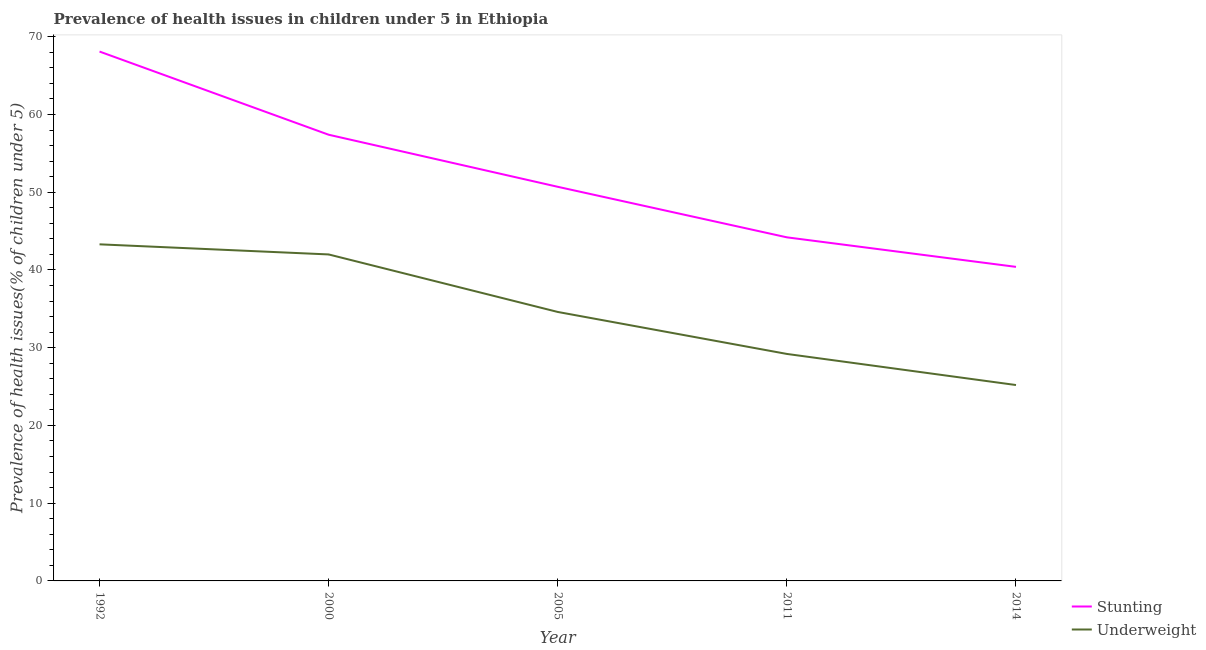What is the percentage of stunted children in 1992?
Your answer should be compact. 68.1. Across all years, what is the maximum percentage of stunted children?
Provide a short and direct response. 68.1. Across all years, what is the minimum percentage of stunted children?
Provide a succinct answer. 40.4. In which year was the percentage of underweight children maximum?
Give a very brief answer. 1992. What is the total percentage of underweight children in the graph?
Provide a short and direct response. 174.3. What is the difference between the percentage of underweight children in 1992 and that in 2005?
Give a very brief answer. 8.7. What is the difference between the percentage of underweight children in 2005 and the percentage of stunted children in 2000?
Offer a very short reply. -22.8. What is the average percentage of underweight children per year?
Offer a very short reply. 34.86. In the year 2014, what is the difference between the percentage of stunted children and percentage of underweight children?
Provide a succinct answer. 15.2. In how many years, is the percentage of stunted children greater than 20 %?
Your answer should be very brief. 5. What is the ratio of the percentage of underweight children in 2005 to that in 2011?
Provide a short and direct response. 1.18. Is the difference between the percentage of stunted children in 2000 and 2014 greater than the difference between the percentage of underweight children in 2000 and 2014?
Keep it short and to the point. Yes. What is the difference between the highest and the second highest percentage of stunted children?
Provide a short and direct response. 10.7. What is the difference between the highest and the lowest percentage of underweight children?
Make the answer very short. 18.1. Is the sum of the percentage of stunted children in 2000 and 2011 greater than the maximum percentage of underweight children across all years?
Your answer should be compact. Yes. Does the percentage of stunted children monotonically increase over the years?
Ensure brevity in your answer.  No. How many lines are there?
Offer a very short reply. 2. What is the difference between two consecutive major ticks on the Y-axis?
Make the answer very short. 10. Are the values on the major ticks of Y-axis written in scientific E-notation?
Your answer should be very brief. No. Does the graph contain any zero values?
Make the answer very short. No. Does the graph contain grids?
Provide a short and direct response. No. How many legend labels are there?
Ensure brevity in your answer.  2. What is the title of the graph?
Your response must be concise. Prevalence of health issues in children under 5 in Ethiopia. What is the label or title of the Y-axis?
Make the answer very short. Prevalence of health issues(% of children under 5). What is the Prevalence of health issues(% of children under 5) of Stunting in 1992?
Keep it short and to the point. 68.1. What is the Prevalence of health issues(% of children under 5) in Underweight in 1992?
Offer a terse response. 43.3. What is the Prevalence of health issues(% of children under 5) of Stunting in 2000?
Offer a terse response. 57.4. What is the Prevalence of health issues(% of children under 5) in Underweight in 2000?
Your response must be concise. 42. What is the Prevalence of health issues(% of children under 5) of Stunting in 2005?
Provide a short and direct response. 50.7. What is the Prevalence of health issues(% of children under 5) in Underweight in 2005?
Make the answer very short. 34.6. What is the Prevalence of health issues(% of children under 5) of Stunting in 2011?
Offer a terse response. 44.2. What is the Prevalence of health issues(% of children under 5) in Underweight in 2011?
Your answer should be compact. 29.2. What is the Prevalence of health issues(% of children under 5) of Stunting in 2014?
Provide a short and direct response. 40.4. What is the Prevalence of health issues(% of children under 5) in Underweight in 2014?
Give a very brief answer. 25.2. Across all years, what is the maximum Prevalence of health issues(% of children under 5) in Stunting?
Make the answer very short. 68.1. Across all years, what is the maximum Prevalence of health issues(% of children under 5) in Underweight?
Offer a terse response. 43.3. Across all years, what is the minimum Prevalence of health issues(% of children under 5) in Stunting?
Offer a terse response. 40.4. Across all years, what is the minimum Prevalence of health issues(% of children under 5) in Underweight?
Your answer should be compact. 25.2. What is the total Prevalence of health issues(% of children under 5) in Stunting in the graph?
Offer a terse response. 260.8. What is the total Prevalence of health issues(% of children under 5) in Underweight in the graph?
Offer a terse response. 174.3. What is the difference between the Prevalence of health issues(% of children under 5) in Underweight in 1992 and that in 2000?
Give a very brief answer. 1.3. What is the difference between the Prevalence of health issues(% of children under 5) of Stunting in 1992 and that in 2005?
Provide a succinct answer. 17.4. What is the difference between the Prevalence of health issues(% of children under 5) in Underweight in 1992 and that in 2005?
Offer a terse response. 8.7. What is the difference between the Prevalence of health issues(% of children under 5) of Stunting in 1992 and that in 2011?
Your response must be concise. 23.9. What is the difference between the Prevalence of health issues(% of children under 5) in Underweight in 1992 and that in 2011?
Offer a terse response. 14.1. What is the difference between the Prevalence of health issues(% of children under 5) in Stunting in 1992 and that in 2014?
Provide a succinct answer. 27.7. What is the difference between the Prevalence of health issues(% of children under 5) in Underweight in 1992 and that in 2014?
Offer a very short reply. 18.1. What is the difference between the Prevalence of health issues(% of children under 5) in Stunting in 2000 and that in 2005?
Give a very brief answer. 6.7. What is the difference between the Prevalence of health issues(% of children under 5) in Stunting in 2000 and that in 2011?
Your answer should be compact. 13.2. What is the difference between the Prevalence of health issues(% of children under 5) in Underweight in 2000 and that in 2011?
Ensure brevity in your answer.  12.8. What is the difference between the Prevalence of health issues(% of children under 5) of Stunting in 2005 and that in 2014?
Your answer should be very brief. 10.3. What is the difference between the Prevalence of health issues(% of children under 5) in Stunting in 2011 and that in 2014?
Offer a terse response. 3.8. What is the difference between the Prevalence of health issues(% of children under 5) of Underweight in 2011 and that in 2014?
Ensure brevity in your answer.  4. What is the difference between the Prevalence of health issues(% of children under 5) of Stunting in 1992 and the Prevalence of health issues(% of children under 5) of Underweight in 2000?
Provide a succinct answer. 26.1. What is the difference between the Prevalence of health issues(% of children under 5) of Stunting in 1992 and the Prevalence of health issues(% of children under 5) of Underweight in 2005?
Make the answer very short. 33.5. What is the difference between the Prevalence of health issues(% of children under 5) of Stunting in 1992 and the Prevalence of health issues(% of children under 5) of Underweight in 2011?
Make the answer very short. 38.9. What is the difference between the Prevalence of health issues(% of children under 5) of Stunting in 1992 and the Prevalence of health issues(% of children under 5) of Underweight in 2014?
Offer a terse response. 42.9. What is the difference between the Prevalence of health issues(% of children under 5) of Stunting in 2000 and the Prevalence of health issues(% of children under 5) of Underweight in 2005?
Offer a terse response. 22.8. What is the difference between the Prevalence of health issues(% of children under 5) in Stunting in 2000 and the Prevalence of health issues(% of children under 5) in Underweight in 2011?
Give a very brief answer. 28.2. What is the difference between the Prevalence of health issues(% of children under 5) of Stunting in 2000 and the Prevalence of health issues(% of children under 5) of Underweight in 2014?
Provide a succinct answer. 32.2. What is the difference between the Prevalence of health issues(% of children under 5) in Stunting in 2005 and the Prevalence of health issues(% of children under 5) in Underweight in 2011?
Keep it short and to the point. 21.5. What is the difference between the Prevalence of health issues(% of children under 5) in Stunting in 2005 and the Prevalence of health issues(% of children under 5) in Underweight in 2014?
Give a very brief answer. 25.5. What is the average Prevalence of health issues(% of children under 5) in Stunting per year?
Offer a very short reply. 52.16. What is the average Prevalence of health issues(% of children under 5) in Underweight per year?
Give a very brief answer. 34.86. In the year 1992, what is the difference between the Prevalence of health issues(% of children under 5) of Stunting and Prevalence of health issues(% of children under 5) of Underweight?
Keep it short and to the point. 24.8. What is the ratio of the Prevalence of health issues(% of children under 5) in Stunting in 1992 to that in 2000?
Your answer should be compact. 1.19. What is the ratio of the Prevalence of health issues(% of children under 5) in Underweight in 1992 to that in 2000?
Give a very brief answer. 1.03. What is the ratio of the Prevalence of health issues(% of children under 5) of Stunting in 1992 to that in 2005?
Provide a succinct answer. 1.34. What is the ratio of the Prevalence of health issues(% of children under 5) of Underweight in 1992 to that in 2005?
Ensure brevity in your answer.  1.25. What is the ratio of the Prevalence of health issues(% of children under 5) of Stunting in 1992 to that in 2011?
Your answer should be compact. 1.54. What is the ratio of the Prevalence of health issues(% of children under 5) in Underweight in 1992 to that in 2011?
Provide a succinct answer. 1.48. What is the ratio of the Prevalence of health issues(% of children under 5) in Stunting in 1992 to that in 2014?
Give a very brief answer. 1.69. What is the ratio of the Prevalence of health issues(% of children under 5) of Underweight in 1992 to that in 2014?
Give a very brief answer. 1.72. What is the ratio of the Prevalence of health issues(% of children under 5) in Stunting in 2000 to that in 2005?
Ensure brevity in your answer.  1.13. What is the ratio of the Prevalence of health issues(% of children under 5) in Underweight in 2000 to that in 2005?
Your response must be concise. 1.21. What is the ratio of the Prevalence of health issues(% of children under 5) in Stunting in 2000 to that in 2011?
Your response must be concise. 1.3. What is the ratio of the Prevalence of health issues(% of children under 5) in Underweight in 2000 to that in 2011?
Offer a terse response. 1.44. What is the ratio of the Prevalence of health issues(% of children under 5) of Stunting in 2000 to that in 2014?
Provide a succinct answer. 1.42. What is the ratio of the Prevalence of health issues(% of children under 5) of Stunting in 2005 to that in 2011?
Offer a very short reply. 1.15. What is the ratio of the Prevalence of health issues(% of children under 5) in Underweight in 2005 to that in 2011?
Your response must be concise. 1.18. What is the ratio of the Prevalence of health issues(% of children under 5) of Stunting in 2005 to that in 2014?
Your response must be concise. 1.25. What is the ratio of the Prevalence of health issues(% of children under 5) in Underweight in 2005 to that in 2014?
Offer a terse response. 1.37. What is the ratio of the Prevalence of health issues(% of children under 5) in Stunting in 2011 to that in 2014?
Give a very brief answer. 1.09. What is the ratio of the Prevalence of health issues(% of children under 5) in Underweight in 2011 to that in 2014?
Make the answer very short. 1.16. What is the difference between the highest and the second highest Prevalence of health issues(% of children under 5) in Stunting?
Make the answer very short. 10.7. What is the difference between the highest and the second highest Prevalence of health issues(% of children under 5) in Underweight?
Keep it short and to the point. 1.3. What is the difference between the highest and the lowest Prevalence of health issues(% of children under 5) in Stunting?
Make the answer very short. 27.7. 